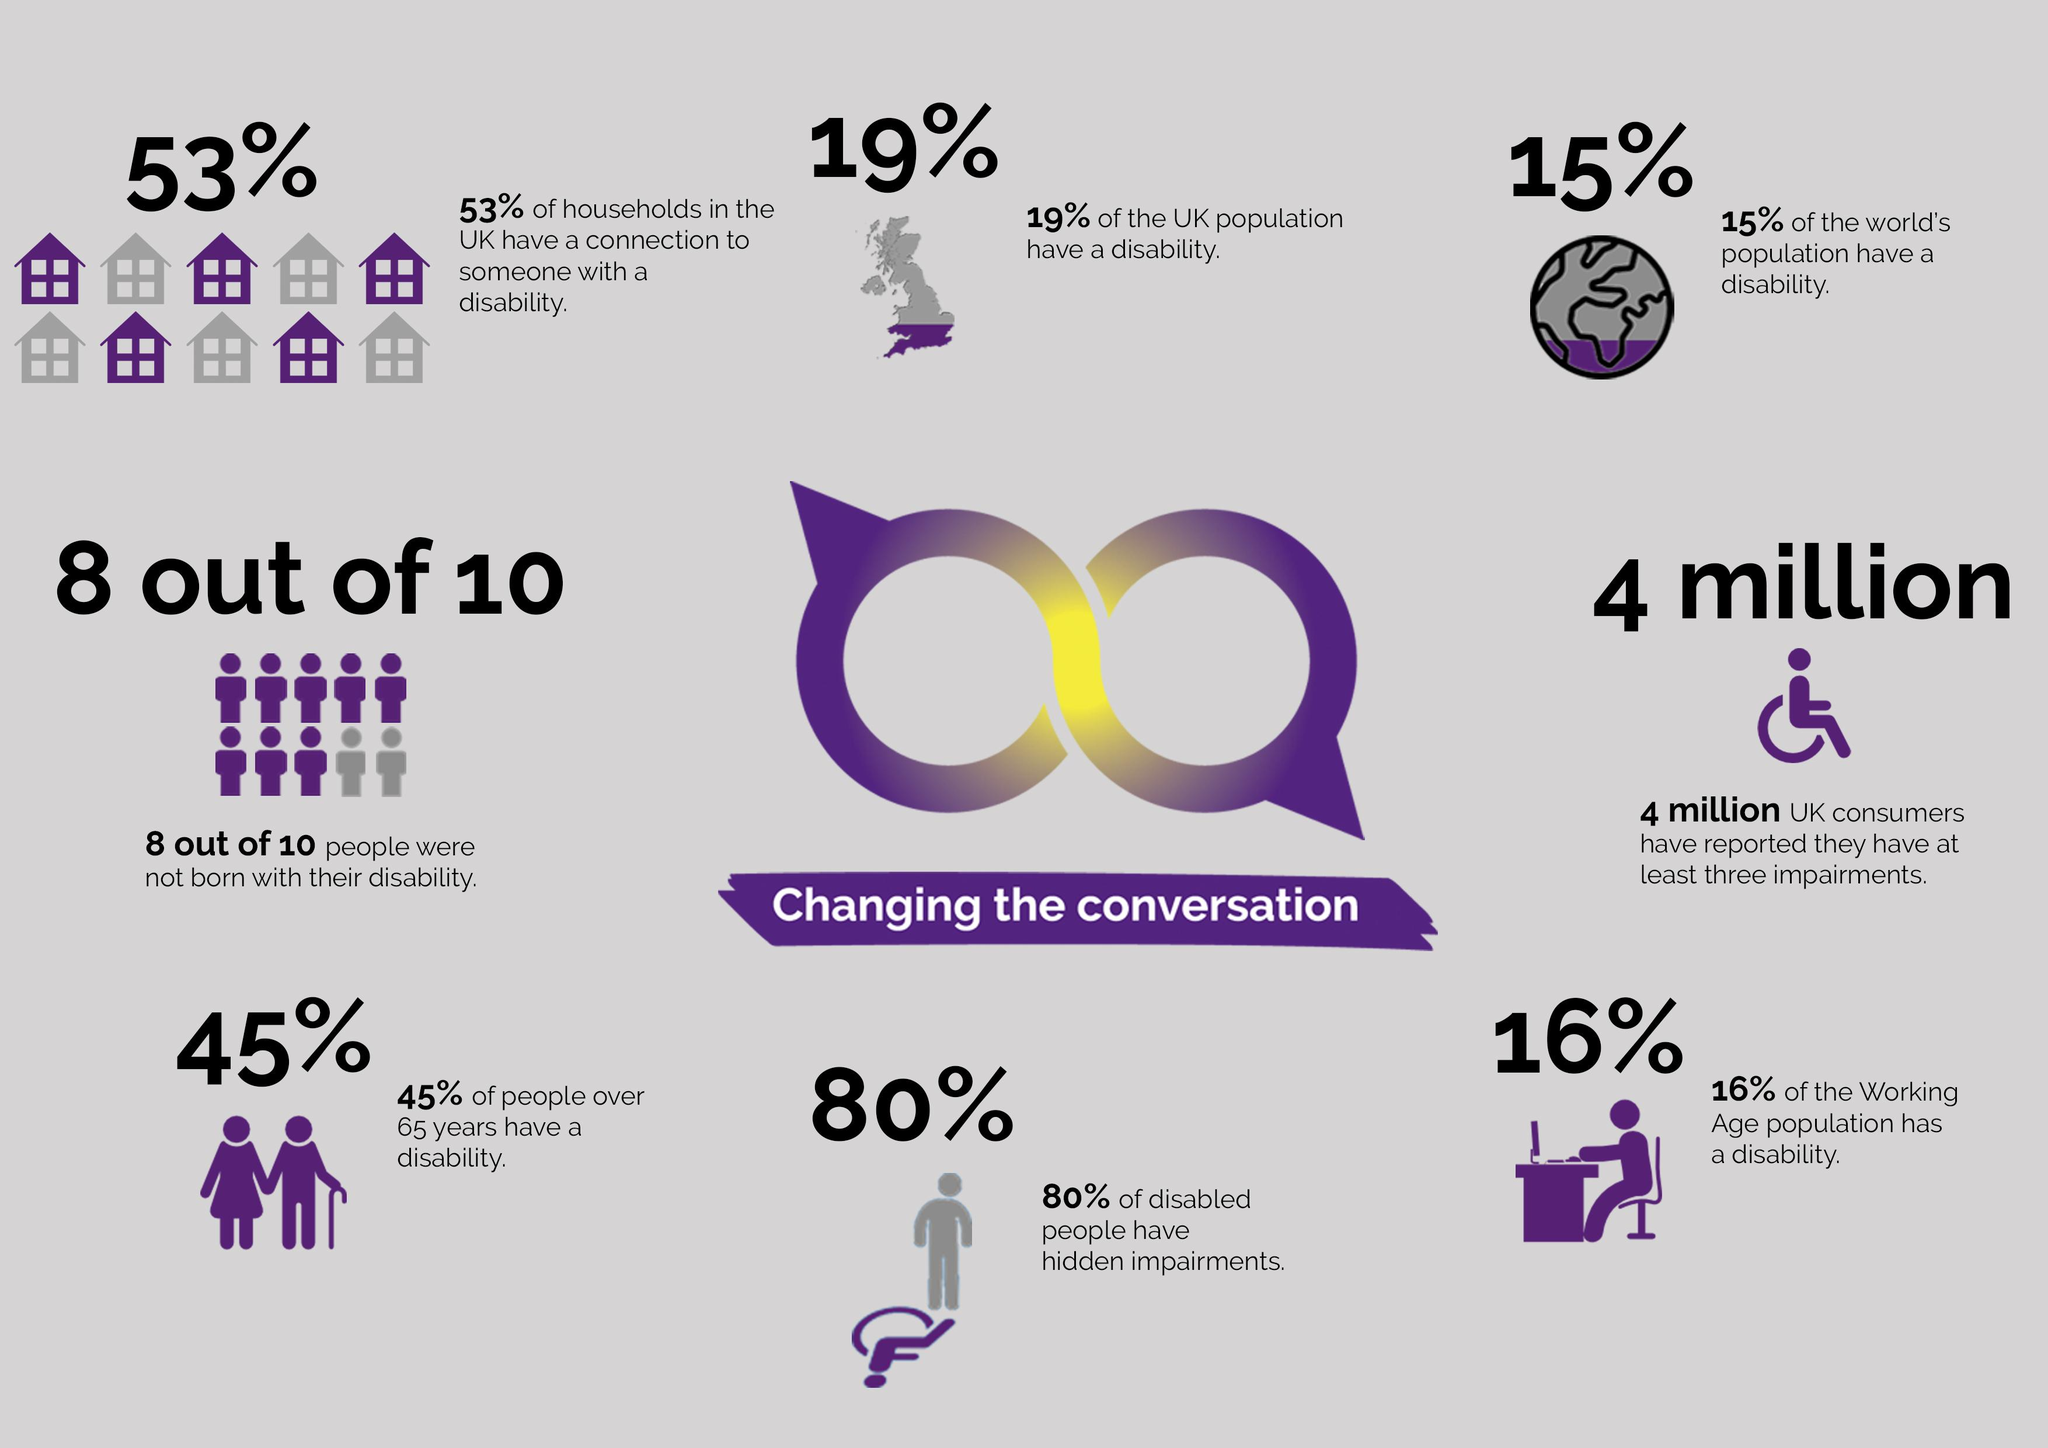Point out several critical features in this image. It is estimated that 85% of the world's population does not have a disability. In the UK, approximately 81% of the population does not have a disability. 